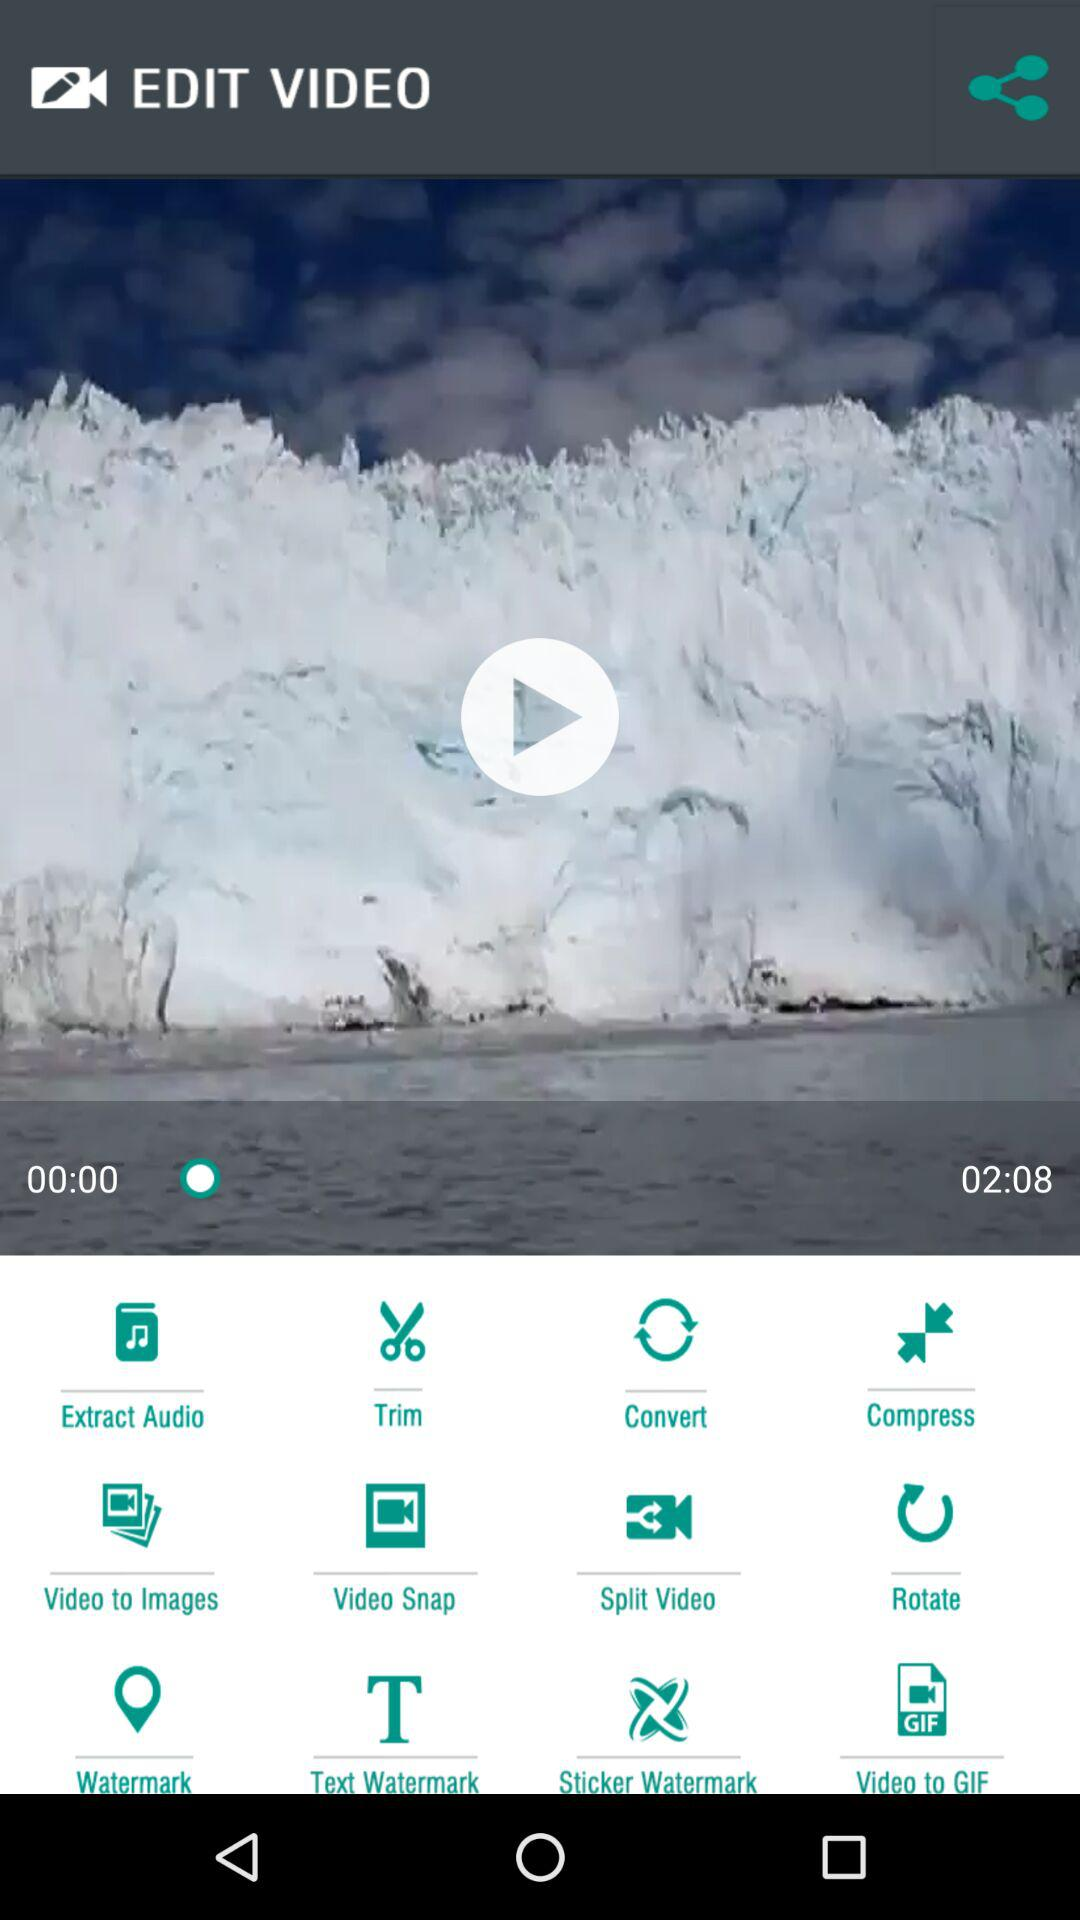What are the different tools that can be used? The different tools that can be used are "Extract Audio", "Trim", "Convert", "Compress", "Video to Images", "Video Snap", "Split Video", "Rotate", "Watermark", "Text Watermark", "Sticker Watermark" and "Video to GIF". 